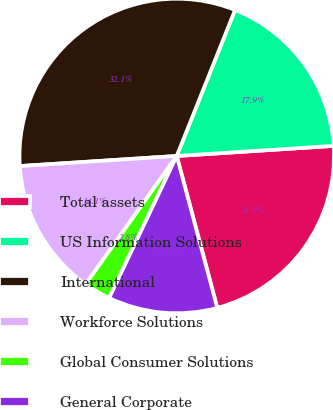<chart> <loc_0><loc_0><loc_500><loc_500><pie_chart><fcel>Total assets<fcel>US Information Solutions<fcel>International<fcel>Workforce Solutions<fcel>Global Consumer Solutions<fcel>General Corporate<nl><fcel>21.87%<fcel>17.93%<fcel>32.07%<fcel>14.15%<fcel>2.76%<fcel>11.22%<nl></chart> 